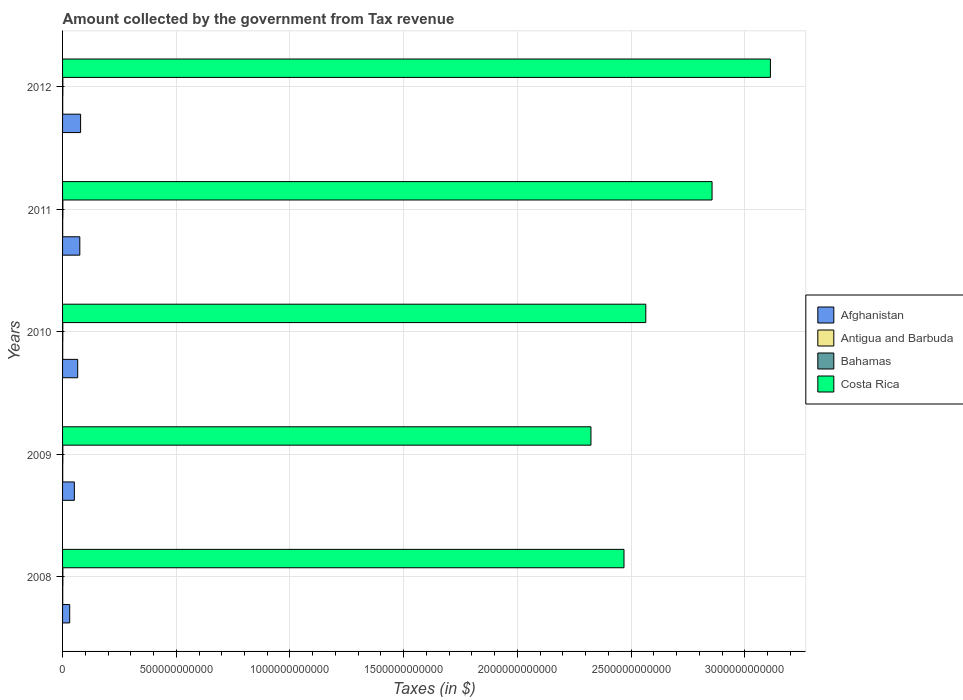How many different coloured bars are there?
Provide a short and direct response. 4. How many groups of bars are there?
Make the answer very short. 5. Are the number of bars on each tick of the Y-axis equal?
Provide a succinct answer. Yes. How many bars are there on the 1st tick from the top?
Give a very brief answer. 4. How many bars are there on the 2nd tick from the bottom?
Keep it short and to the point. 4. What is the label of the 1st group of bars from the top?
Provide a short and direct response. 2012. What is the amount collected by the government from tax revenue in Antigua and Barbuda in 2008?
Provide a succinct answer. 6.92e+08. Across all years, what is the maximum amount collected by the government from tax revenue in Costa Rica?
Keep it short and to the point. 3.11e+12. Across all years, what is the minimum amount collected by the government from tax revenue in Afghanistan?
Provide a short and direct response. 3.14e+1. In which year was the amount collected by the government from tax revenue in Afghanistan maximum?
Make the answer very short. 2012. What is the total amount collected by the government from tax revenue in Antigua and Barbuda in the graph?
Your response must be concise. 3.00e+09. What is the difference between the amount collected by the government from tax revenue in Costa Rica in 2010 and that in 2012?
Ensure brevity in your answer.  -5.48e+11. What is the difference between the amount collected by the government from tax revenue in Afghanistan in 2010 and the amount collected by the government from tax revenue in Antigua and Barbuda in 2012?
Ensure brevity in your answer.  6.60e+1. What is the average amount collected by the government from tax revenue in Antigua and Barbuda per year?
Keep it short and to the point. 6.00e+08. In the year 2011, what is the difference between the amount collected by the government from tax revenue in Bahamas and amount collected by the government from tax revenue in Costa Rica?
Provide a short and direct response. -2.85e+12. In how many years, is the amount collected by the government from tax revenue in Costa Rica greater than 1300000000000 $?
Offer a terse response. 5. What is the ratio of the amount collected by the government from tax revenue in Bahamas in 2008 to that in 2010?
Your response must be concise. 1.16. Is the difference between the amount collected by the government from tax revenue in Bahamas in 2011 and 2012 greater than the difference between the amount collected by the government from tax revenue in Costa Rica in 2011 and 2012?
Provide a short and direct response. Yes. What is the difference between the highest and the second highest amount collected by the government from tax revenue in Antigua and Barbuda?
Your response must be concise. 8.82e+07. What is the difference between the highest and the lowest amount collected by the government from tax revenue in Costa Rica?
Offer a terse response. 7.89e+11. In how many years, is the amount collected by the government from tax revenue in Costa Rica greater than the average amount collected by the government from tax revenue in Costa Rica taken over all years?
Your response must be concise. 2. Is it the case that in every year, the sum of the amount collected by the government from tax revenue in Bahamas and amount collected by the government from tax revenue in Antigua and Barbuda is greater than the sum of amount collected by the government from tax revenue in Costa Rica and amount collected by the government from tax revenue in Afghanistan?
Keep it short and to the point. No. What does the 4th bar from the top in 2011 represents?
Keep it short and to the point. Afghanistan. What does the 1st bar from the bottom in 2009 represents?
Ensure brevity in your answer.  Afghanistan. Is it the case that in every year, the sum of the amount collected by the government from tax revenue in Afghanistan and amount collected by the government from tax revenue in Antigua and Barbuda is greater than the amount collected by the government from tax revenue in Bahamas?
Keep it short and to the point. Yes. Are all the bars in the graph horizontal?
Your answer should be compact. Yes. How many years are there in the graph?
Keep it short and to the point. 5. What is the difference between two consecutive major ticks on the X-axis?
Your answer should be very brief. 5.00e+11. Where does the legend appear in the graph?
Give a very brief answer. Center right. How many legend labels are there?
Offer a very short reply. 4. How are the legend labels stacked?
Ensure brevity in your answer.  Vertical. What is the title of the graph?
Ensure brevity in your answer.  Amount collected by the government from Tax revenue. Does "St. Vincent and the Grenadines" appear as one of the legend labels in the graph?
Provide a short and direct response. No. What is the label or title of the X-axis?
Your response must be concise. Taxes (in $). What is the Taxes (in $) in Afghanistan in 2008?
Provide a short and direct response. 3.14e+1. What is the Taxes (in $) of Antigua and Barbuda in 2008?
Give a very brief answer. 6.92e+08. What is the Taxes (in $) of Bahamas in 2008?
Offer a terse response. 1.28e+09. What is the Taxes (in $) in Costa Rica in 2008?
Offer a terse response. 2.47e+12. What is the Taxes (in $) in Afghanistan in 2009?
Your response must be concise. 5.19e+1. What is the Taxes (in $) in Antigua and Barbuda in 2009?
Provide a succinct answer. 5.73e+08. What is the Taxes (in $) in Bahamas in 2009?
Keep it short and to the point. 1.12e+09. What is the Taxes (in $) in Costa Rica in 2009?
Provide a short and direct response. 2.32e+12. What is the Taxes (in $) of Afghanistan in 2010?
Provide a short and direct response. 6.66e+1. What is the Taxes (in $) of Antigua and Barbuda in 2010?
Provide a short and direct response. 5.76e+08. What is the Taxes (in $) in Bahamas in 2010?
Give a very brief answer. 1.10e+09. What is the Taxes (in $) in Costa Rica in 2010?
Offer a terse response. 2.56e+12. What is the Taxes (in $) in Afghanistan in 2011?
Offer a terse response. 7.58e+1. What is the Taxes (in $) in Antigua and Barbuda in 2011?
Give a very brief answer. 5.51e+08. What is the Taxes (in $) in Bahamas in 2011?
Your answer should be very brief. 1.30e+09. What is the Taxes (in $) of Costa Rica in 2011?
Keep it short and to the point. 2.86e+12. What is the Taxes (in $) in Afghanistan in 2012?
Keep it short and to the point. 7.93e+1. What is the Taxes (in $) in Antigua and Barbuda in 2012?
Keep it short and to the point. 6.04e+08. What is the Taxes (in $) of Bahamas in 2012?
Offer a terse response. 1.28e+09. What is the Taxes (in $) of Costa Rica in 2012?
Make the answer very short. 3.11e+12. Across all years, what is the maximum Taxes (in $) in Afghanistan?
Provide a short and direct response. 7.93e+1. Across all years, what is the maximum Taxes (in $) in Antigua and Barbuda?
Keep it short and to the point. 6.92e+08. Across all years, what is the maximum Taxes (in $) in Bahamas?
Make the answer very short. 1.30e+09. Across all years, what is the maximum Taxes (in $) in Costa Rica?
Provide a short and direct response. 3.11e+12. Across all years, what is the minimum Taxes (in $) in Afghanistan?
Your answer should be very brief. 3.14e+1. Across all years, what is the minimum Taxes (in $) of Antigua and Barbuda?
Provide a short and direct response. 5.51e+08. Across all years, what is the minimum Taxes (in $) of Bahamas?
Ensure brevity in your answer.  1.10e+09. Across all years, what is the minimum Taxes (in $) of Costa Rica?
Give a very brief answer. 2.32e+12. What is the total Taxes (in $) in Afghanistan in the graph?
Ensure brevity in your answer.  3.05e+11. What is the total Taxes (in $) of Antigua and Barbuda in the graph?
Your answer should be compact. 3.00e+09. What is the total Taxes (in $) of Bahamas in the graph?
Ensure brevity in your answer.  6.07e+09. What is the total Taxes (in $) of Costa Rica in the graph?
Your answer should be compact. 1.33e+13. What is the difference between the Taxes (in $) of Afghanistan in 2008 and that in 2009?
Ensure brevity in your answer.  -2.05e+1. What is the difference between the Taxes (in $) in Antigua and Barbuda in 2008 and that in 2009?
Make the answer very short. 1.19e+08. What is the difference between the Taxes (in $) of Bahamas in 2008 and that in 2009?
Offer a very short reply. 1.53e+08. What is the difference between the Taxes (in $) in Costa Rica in 2008 and that in 2009?
Give a very brief answer. 1.45e+11. What is the difference between the Taxes (in $) of Afghanistan in 2008 and that in 2010?
Provide a short and direct response. -3.52e+1. What is the difference between the Taxes (in $) of Antigua and Barbuda in 2008 and that in 2010?
Give a very brief answer. 1.16e+08. What is the difference between the Taxes (in $) of Bahamas in 2008 and that in 2010?
Your response must be concise. 1.78e+08. What is the difference between the Taxes (in $) of Costa Rica in 2008 and that in 2010?
Your answer should be compact. -9.58e+1. What is the difference between the Taxes (in $) in Afghanistan in 2008 and that in 2011?
Make the answer very short. -4.45e+1. What is the difference between the Taxes (in $) of Antigua and Barbuda in 2008 and that in 2011?
Your answer should be very brief. 1.41e+08. What is the difference between the Taxes (in $) of Bahamas in 2008 and that in 2011?
Your answer should be very brief. -2.10e+07. What is the difference between the Taxes (in $) in Costa Rica in 2008 and that in 2011?
Make the answer very short. -3.87e+11. What is the difference between the Taxes (in $) of Afghanistan in 2008 and that in 2012?
Keep it short and to the point. -4.79e+1. What is the difference between the Taxes (in $) of Antigua and Barbuda in 2008 and that in 2012?
Your answer should be very brief. 8.82e+07. What is the difference between the Taxes (in $) of Bahamas in 2008 and that in 2012?
Offer a terse response. -7.50e+05. What is the difference between the Taxes (in $) in Costa Rica in 2008 and that in 2012?
Your answer should be compact. -6.44e+11. What is the difference between the Taxes (in $) in Afghanistan in 2009 and that in 2010?
Your response must be concise. -1.47e+1. What is the difference between the Taxes (in $) of Antigua and Barbuda in 2009 and that in 2010?
Your answer should be compact. -3.10e+06. What is the difference between the Taxes (in $) of Bahamas in 2009 and that in 2010?
Your response must be concise. 2.51e+07. What is the difference between the Taxes (in $) in Costa Rica in 2009 and that in 2010?
Provide a short and direct response. -2.41e+11. What is the difference between the Taxes (in $) in Afghanistan in 2009 and that in 2011?
Offer a very short reply. -2.39e+1. What is the difference between the Taxes (in $) in Antigua and Barbuda in 2009 and that in 2011?
Provide a short and direct response. 2.20e+07. What is the difference between the Taxes (in $) of Bahamas in 2009 and that in 2011?
Your answer should be compact. -1.74e+08. What is the difference between the Taxes (in $) in Costa Rica in 2009 and that in 2011?
Your response must be concise. -5.33e+11. What is the difference between the Taxes (in $) in Afghanistan in 2009 and that in 2012?
Provide a succinct answer. -2.74e+1. What is the difference between the Taxes (in $) in Antigua and Barbuda in 2009 and that in 2012?
Keep it short and to the point. -3.08e+07. What is the difference between the Taxes (in $) in Bahamas in 2009 and that in 2012?
Your response must be concise. -1.53e+08. What is the difference between the Taxes (in $) in Costa Rica in 2009 and that in 2012?
Ensure brevity in your answer.  -7.89e+11. What is the difference between the Taxes (in $) in Afghanistan in 2010 and that in 2011?
Provide a short and direct response. -9.23e+09. What is the difference between the Taxes (in $) in Antigua and Barbuda in 2010 and that in 2011?
Provide a short and direct response. 2.51e+07. What is the difference between the Taxes (in $) in Bahamas in 2010 and that in 2011?
Ensure brevity in your answer.  -1.99e+08. What is the difference between the Taxes (in $) in Costa Rica in 2010 and that in 2011?
Your response must be concise. -2.91e+11. What is the difference between the Taxes (in $) of Afghanistan in 2010 and that in 2012?
Provide a succinct answer. -1.27e+1. What is the difference between the Taxes (in $) in Antigua and Barbuda in 2010 and that in 2012?
Keep it short and to the point. -2.77e+07. What is the difference between the Taxes (in $) in Bahamas in 2010 and that in 2012?
Offer a very short reply. -1.79e+08. What is the difference between the Taxes (in $) in Costa Rica in 2010 and that in 2012?
Your answer should be compact. -5.48e+11. What is the difference between the Taxes (in $) in Afghanistan in 2011 and that in 2012?
Your answer should be compact. -3.47e+09. What is the difference between the Taxes (in $) in Antigua and Barbuda in 2011 and that in 2012?
Offer a very short reply. -5.28e+07. What is the difference between the Taxes (in $) in Bahamas in 2011 and that in 2012?
Offer a terse response. 2.03e+07. What is the difference between the Taxes (in $) of Costa Rica in 2011 and that in 2012?
Your answer should be compact. -2.57e+11. What is the difference between the Taxes (in $) of Afghanistan in 2008 and the Taxes (in $) of Antigua and Barbuda in 2009?
Your response must be concise. 3.08e+1. What is the difference between the Taxes (in $) in Afghanistan in 2008 and the Taxes (in $) in Bahamas in 2009?
Ensure brevity in your answer.  3.02e+1. What is the difference between the Taxes (in $) in Afghanistan in 2008 and the Taxes (in $) in Costa Rica in 2009?
Ensure brevity in your answer.  -2.29e+12. What is the difference between the Taxes (in $) of Antigua and Barbuda in 2008 and the Taxes (in $) of Bahamas in 2009?
Give a very brief answer. -4.31e+08. What is the difference between the Taxes (in $) of Antigua and Barbuda in 2008 and the Taxes (in $) of Costa Rica in 2009?
Make the answer very short. -2.32e+12. What is the difference between the Taxes (in $) of Bahamas in 2008 and the Taxes (in $) of Costa Rica in 2009?
Your answer should be compact. -2.32e+12. What is the difference between the Taxes (in $) in Afghanistan in 2008 and the Taxes (in $) in Antigua and Barbuda in 2010?
Offer a very short reply. 3.08e+1. What is the difference between the Taxes (in $) of Afghanistan in 2008 and the Taxes (in $) of Bahamas in 2010?
Offer a very short reply. 3.03e+1. What is the difference between the Taxes (in $) in Afghanistan in 2008 and the Taxes (in $) in Costa Rica in 2010?
Make the answer very short. -2.53e+12. What is the difference between the Taxes (in $) in Antigua and Barbuda in 2008 and the Taxes (in $) in Bahamas in 2010?
Ensure brevity in your answer.  -4.06e+08. What is the difference between the Taxes (in $) of Antigua and Barbuda in 2008 and the Taxes (in $) of Costa Rica in 2010?
Keep it short and to the point. -2.56e+12. What is the difference between the Taxes (in $) of Bahamas in 2008 and the Taxes (in $) of Costa Rica in 2010?
Keep it short and to the point. -2.56e+12. What is the difference between the Taxes (in $) in Afghanistan in 2008 and the Taxes (in $) in Antigua and Barbuda in 2011?
Give a very brief answer. 3.08e+1. What is the difference between the Taxes (in $) in Afghanistan in 2008 and the Taxes (in $) in Bahamas in 2011?
Provide a short and direct response. 3.01e+1. What is the difference between the Taxes (in $) of Afghanistan in 2008 and the Taxes (in $) of Costa Rica in 2011?
Your response must be concise. -2.82e+12. What is the difference between the Taxes (in $) in Antigua and Barbuda in 2008 and the Taxes (in $) in Bahamas in 2011?
Provide a succinct answer. -6.05e+08. What is the difference between the Taxes (in $) of Antigua and Barbuda in 2008 and the Taxes (in $) of Costa Rica in 2011?
Make the answer very short. -2.86e+12. What is the difference between the Taxes (in $) of Bahamas in 2008 and the Taxes (in $) of Costa Rica in 2011?
Your answer should be very brief. -2.85e+12. What is the difference between the Taxes (in $) of Afghanistan in 2008 and the Taxes (in $) of Antigua and Barbuda in 2012?
Your answer should be very brief. 3.08e+1. What is the difference between the Taxes (in $) in Afghanistan in 2008 and the Taxes (in $) in Bahamas in 2012?
Provide a short and direct response. 3.01e+1. What is the difference between the Taxes (in $) of Afghanistan in 2008 and the Taxes (in $) of Costa Rica in 2012?
Provide a succinct answer. -3.08e+12. What is the difference between the Taxes (in $) in Antigua and Barbuda in 2008 and the Taxes (in $) in Bahamas in 2012?
Your answer should be compact. -5.84e+08. What is the difference between the Taxes (in $) of Antigua and Barbuda in 2008 and the Taxes (in $) of Costa Rica in 2012?
Provide a short and direct response. -3.11e+12. What is the difference between the Taxes (in $) in Bahamas in 2008 and the Taxes (in $) in Costa Rica in 2012?
Keep it short and to the point. -3.11e+12. What is the difference between the Taxes (in $) in Afghanistan in 2009 and the Taxes (in $) in Antigua and Barbuda in 2010?
Offer a terse response. 5.13e+1. What is the difference between the Taxes (in $) in Afghanistan in 2009 and the Taxes (in $) in Bahamas in 2010?
Ensure brevity in your answer.  5.08e+1. What is the difference between the Taxes (in $) in Afghanistan in 2009 and the Taxes (in $) in Costa Rica in 2010?
Offer a very short reply. -2.51e+12. What is the difference between the Taxes (in $) in Antigua and Barbuda in 2009 and the Taxes (in $) in Bahamas in 2010?
Provide a short and direct response. -5.25e+08. What is the difference between the Taxes (in $) in Antigua and Barbuda in 2009 and the Taxes (in $) in Costa Rica in 2010?
Offer a terse response. -2.56e+12. What is the difference between the Taxes (in $) in Bahamas in 2009 and the Taxes (in $) in Costa Rica in 2010?
Your answer should be compact. -2.56e+12. What is the difference between the Taxes (in $) of Afghanistan in 2009 and the Taxes (in $) of Antigua and Barbuda in 2011?
Offer a very short reply. 5.13e+1. What is the difference between the Taxes (in $) of Afghanistan in 2009 and the Taxes (in $) of Bahamas in 2011?
Give a very brief answer. 5.06e+1. What is the difference between the Taxes (in $) of Afghanistan in 2009 and the Taxes (in $) of Costa Rica in 2011?
Provide a succinct answer. -2.80e+12. What is the difference between the Taxes (in $) in Antigua and Barbuda in 2009 and the Taxes (in $) in Bahamas in 2011?
Make the answer very short. -7.24e+08. What is the difference between the Taxes (in $) of Antigua and Barbuda in 2009 and the Taxes (in $) of Costa Rica in 2011?
Provide a succinct answer. -2.86e+12. What is the difference between the Taxes (in $) of Bahamas in 2009 and the Taxes (in $) of Costa Rica in 2011?
Ensure brevity in your answer.  -2.86e+12. What is the difference between the Taxes (in $) of Afghanistan in 2009 and the Taxes (in $) of Antigua and Barbuda in 2012?
Give a very brief answer. 5.13e+1. What is the difference between the Taxes (in $) of Afghanistan in 2009 and the Taxes (in $) of Bahamas in 2012?
Your response must be concise. 5.06e+1. What is the difference between the Taxes (in $) in Afghanistan in 2009 and the Taxes (in $) in Costa Rica in 2012?
Offer a very short reply. -3.06e+12. What is the difference between the Taxes (in $) in Antigua and Barbuda in 2009 and the Taxes (in $) in Bahamas in 2012?
Provide a short and direct response. -7.03e+08. What is the difference between the Taxes (in $) in Antigua and Barbuda in 2009 and the Taxes (in $) in Costa Rica in 2012?
Make the answer very short. -3.11e+12. What is the difference between the Taxes (in $) in Bahamas in 2009 and the Taxes (in $) in Costa Rica in 2012?
Your response must be concise. -3.11e+12. What is the difference between the Taxes (in $) in Afghanistan in 2010 and the Taxes (in $) in Antigua and Barbuda in 2011?
Give a very brief answer. 6.60e+1. What is the difference between the Taxes (in $) in Afghanistan in 2010 and the Taxes (in $) in Bahamas in 2011?
Provide a succinct answer. 6.53e+1. What is the difference between the Taxes (in $) of Afghanistan in 2010 and the Taxes (in $) of Costa Rica in 2011?
Give a very brief answer. -2.79e+12. What is the difference between the Taxes (in $) in Antigua and Barbuda in 2010 and the Taxes (in $) in Bahamas in 2011?
Offer a terse response. -7.20e+08. What is the difference between the Taxes (in $) of Antigua and Barbuda in 2010 and the Taxes (in $) of Costa Rica in 2011?
Make the answer very short. -2.86e+12. What is the difference between the Taxes (in $) of Bahamas in 2010 and the Taxes (in $) of Costa Rica in 2011?
Your answer should be very brief. -2.86e+12. What is the difference between the Taxes (in $) in Afghanistan in 2010 and the Taxes (in $) in Antigua and Barbuda in 2012?
Your response must be concise. 6.60e+1. What is the difference between the Taxes (in $) of Afghanistan in 2010 and the Taxes (in $) of Bahamas in 2012?
Give a very brief answer. 6.53e+1. What is the difference between the Taxes (in $) of Afghanistan in 2010 and the Taxes (in $) of Costa Rica in 2012?
Your answer should be compact. -3.05e+12. What is the difference between the Taxes (in $) in Antigua and Barbuda in 2010 and the Taxes (in $) in Bahamas in 2012?
Offer a terse response. -7.00e+08. What is the difference between the Taxes (in $) of Antigua and Barbuda in 2010 and the Taxes (in $) of Costa Rica in 2012?
Give a very brief answer. -3.11e+12. What is the difference between the Taxes (in $) in Bahamas in 2010 and the Taxes (in $) in Costa Rica in 2012?
Your answer should be compact. -3.11e+12. What is the difference between the Taxes (in $) of Afghanistan in 2011 and the Taxes (in $) of Antigua and Barbuda in 2012?
Your answer should be compact. 7.52e+1. What is the difference between the Taxes (in $) in Afghanistan in 2011 and the Taxes (in $) in Bahamas in 2012?
Offer a very short reply. 7.45e+1. What is the difference between the Taxes (in $) of Afghanistan in 2011 and the Taxes (in $) of Costa Rica in 2012?
Your answer should be very brief. -3.04e+12. What is the difference between the Taxes (in $) in Antigua and Barbuda in 2011 and the Taxes (in $) in Bahamas in 2012?
Provide a short and direct response. -7.25e+08. What is the difference between the Taxes (in $) in Antigua and Barbuda in 2011 and the Taxes (in $) in Costa Rica in 2012?
Provide a succinct answer. -3.11e+12. What is the difference between the Taxes (in $) in Bahamas in 2011 and the Taxes (in $) in Costa Rica in 2012?
Keep it short and to the point. -3.11e+12. What is the average Taxes (in $) of Afghanistan per year?
Your answer should be compact. 6.10e+1. What is the average Taxes (in $) in Antigua and Barbuda per year?
Offer a very short reply. 6.00e+08. What is the average Taxes (in $) of Bahamas per year?
Offer a very short reply. 1.21e+09. What is the average Taxes (in $) of Costa Rica per year?
Ensure brevity in your answer.  2.67e+12. In the year 2008, what is the difference between the Taxes (in $) of Afghanistan and Taxes (in $) of Antigua and Barbuda?
Ensure brevity in your answer.  3.07e+1. In the year 2008, what is the difference between the Taxes (in $) in Afghanistan and Taxes (in $) in Bahamas?
Provide a short and direct response. 3.01e+1. In the year 2008, what is the difference between the Taxes (in $) of Afghanistan and Taxes (in $) of Costa Rica?
Give a very brief answer. -2.44e+12. In the year 2008, what is the difference between the Taxes (in $) in Antigua and Barbuda and Taxes (in $) in Bahamas?
Offer a very short reply. -5.83e+08. In the year 2008, what is the difference between the Taxes (in $) of Antigua and Barbuda and Taxes (in $) of Costa Rica?
Ensure brevity in your answer.  -2.47e+12. In the year 2008, what is the difference between the Taxes (in $) in Bahamas and Taxes (in $) in Costa Rica?
Provide a succinct answer. -2.47e+12. In the year 2009, what is the difference between the Taxes (in $) of Afghanistan and Taxes (in $) of Antigua and Barbuda?
Your answer should be compact. 5.13e+1. In the year 2009, what is the difference between the Taxes (in $) in Afghanistan and Taxes (in $) in Bahamas?
Your response must be concise. 5.08e+1. In the year 2009, what is the difference between the Taxes (in $) of Afghanistan and Taxes (in $) of Costa Rica?
Provide a succinct answer. -2.27e+12. In the year 2009, what is the difference between the Taxes (in $) in Antigua and Barbuda and Taxes (in $) in Bahamas?
Give a very brief answer. -5.50e+08. In the year 2009, what is the difference between the Taxes (in $) of Antigua and Barbuda and Taxes (in $) of Costa Rica?
Your answer should be very brief. -2.32e+12. In the year 2009, what is the difference between the Taxes (in $) in Bahamas and Taxes (in $) in Costa Rica?
Provide a short and direct response. -2.32e+12. In the year 2010, what is the difference between the Taxes (in $) in Afghanistan and Taxes (in $) in Antigua and Barbuda?
Provide a succinct answer. 6.60e+1. In the year 2010, what is the difference between the Taxes (in $) of Afghanistan and Taxes (in $) of Bahamas?
Give a very brief answer. 6.55e+1. In the year 2010, what is the difference between the Taxes (in $) of Afghanistan and Taxes (in $) of Costa Rica?
Your answer should be compact. -2.50e+12. In the year 2010, what is the difference between the Taxes (in $) of Antigua and Barbuda and Taxes (in $) of Bahamas?
Ensure brevity in your answer.  -5.22e+08. In the year 2010, what is the difference between the Taxes (in $) in Antigua and Barbuda and Taxes (in $) in Costa Rica?
Your answer should be very brief. -2.56e+12. In the year 2010, what is the difference between the Taxes (in $) of Bahamas and Taxes (in $) of Costa Rica?
Offer a terse response. -2.56e+12. In the year 2011, what is the difference between the Taxes (in $) of Afghanistan and Taxes (in $) of Antigua and Barbuda?
Make the answer very short. 7.53e+1. In the year 2011, what is the difference between the Taxes (in $) in Afghanistan and Taxes (in $) in Bahamas?
Give a very brief answer. 7.45e+1. In the year 2011, what is the difference between the Taxes (in $) in Afghanistan and Taxes (in $) in Costa Rica?
Give a very brief answer. -2.78e+12. In the year 2011, what is the difference between the Taxes (in $) in Antigua and Barbuda and Taxes (in $) in Bahamas?
Make the answer very short. -7.46e+08. In the year 2011, what is the difference between the Taxes (in $) in Antigua and Barbuda and Taxes (in $) in Costa Rica?
Your answer should be compact. -2.86e+12. In the year 2011, what is the difference between the Taxes (in $) of Bahamas and Taxes (in $) of Costa Rica?
Offer a terse response. -2.85e+12. In the year 2012, what is the difference between the Taxes (in $) of Afghanistan and Taxes (in $) of Antigua and Barbuda?
Offer a terse response. 7.87e+1. In the year 2012, what is the difference between the Taxes (in $) of Afghanistan and Taxes (in $) of Bahamas?
Ensure brevity in your answer.  7.80e+1. In the year 2012, what is the difference between the Taxes (in $) in Afghanistan and Taxes (in $) in Costa Rica?
Offer a very short reply. -3.03e+12. In the year 2012, what is the difference between the Taxes (in $) of Antigua and Barbuda and Taxes (in $) of Bahamas?
Your response must be concise. -6.72e+08. In the year 2012, what is the difference between the Taxes (in $) of Antigua and Barbuda and Taxes (in $) of Costa Rica?
Give a very brief answer. -3.11e+12. In the year 2012, what is the difference between the Taxes (in $) in Bahamas and Taxes (in $) in Costa Rica?
Your answer should be very brief. -3.11e+12. What is the ratio of the Taxes (in $) of Afghanistan in 2008 to that in 2009?
Your answer should be very brief. 0.6. What is the ratio of the Taxes (in $) of Antigua and Barbuda in 2008 to that in 2009?
Offer a very short reply. 1.21. What is the ratio of the Taxes (in $) in Bahamas in 2008 to that in 2009?
Offer a very short reply. 1.14. What is the ratio of the Taxes (in $) in Costa Rica in 2008 to that in 2009?
Make the answer very short. 1.06. What is the ratio of the Taxes (in $) of Afghanistan in 2008 to that in 2010?
Your response must be concise. 0.47. What is the ratio of the Taxes (in $) in Antigua and Barbuda in 2008 to that in 2010?
Offer a very short reply. 1.2. What is the ratio of the Taxes (in $) of Bahamas in 2008 to that in 2010?
Keep it short and to the point. 1.16. What is the ratio of the Taxes (in $) of Costa Rica in 2008 to that in 2010?
Your answer should be very brief. 0.96. What is the ratio of the Taxes (in $) of Afghanistan in 2008 to that in 2011?
Offer a very short reply. 0.41. What is the ratio of the Taxes (in $) of Antigua and Barbuda in 2008 to that in 2011?
Provide a succinct answer. 1.26. What is the ratio of the Taxes (in $) of Bahamas in 2008 to that in 2011?
Keep it short and to the point. 0.98. What is the ratio of the Taxes (in $) in Costa Rica in 2008 to that in 2011?
Provide a succinct answer. 0.86. What is the ratio of the Taxes (in $) of Afghanistan in 2008 to that in 2012?
Your answer should be compact. 0.4. What is the ratio of the Taxes (in $) of Antigua and Barbuda in 2008 to that in 2012?
Offer a very short reply. 1.15. What is the ratio of the Taxes (in $) in Bahamas in 2008 to that in 2012?
Ensure brevity in your answer.  1. What is the ratio of the Taxes (in $) of Costa Rica in 2008 to that in 2012?
Offer a terse response. 0.79. What is the ratio of the Taxes (in $) in Afghanistan in 2009 to that in 2010?
Make the answer very short. 0.78. What is the ratio of the Taxes (in $) of Antigua and Barbuda in 2009 to that in 2010?
Offer a terse response. 0.99. What is the ratio of the Taxes (in $) in Bahamas in 2009 to that in 2010?
Keep it short and to the point. 1.02. What is the ratio of the Taxes (in $) in Costa Rica in 2009 to that in 2010?
Offer a terse response. 0.91. What is the ratio of the Taxes (in $) of Afghanistan in 2009 to that in 2011?
Give a very brief answer. 0.68. What is the ratio of the Taxes (in $) in Antigua and Barbuda in 2009 to that in 2011?
Keep it short and to the point. 1.04. What is the ratio of the Taxes (in $) in Bahamas in 2009 to that in 2011?
Make the answer very short. 0.87. What is the ratio of the Taxes (in $) in Costa Rica in 2009 to that in 2011?
Provide a short and direct response. 0.81. What is the ratio of the Taxes (in $) in Afghanistan in 2009 to that in 2012?
Provide a succinct answer. 0.65. What is the ratio of the Taxes (in $) of Antigua and Barbuda in 2009 to that in 2012?
Offer a terse response. 0.95. What is the ratio of the Taxes (in $) of Bahamas in 2009 to that in 2012?
Provide a succinct answer. 0.88. What is the ratio of the Taxes (in $) of Costa Rica in 2009 to that in 2012?
Your response must be concise. 0.75. What is the ratio of the Taxes (in $) of Afghanistan in 2010 to that in 2011?
Your response must be concise. 0.88. What is the ratio of the Taxes (in $) in Antigua and Barbuda in 2010 to that in 2011?
Ensure brevity in your answer.  1.05. What is the ratio of the Taxes (in $) of Bahamas in 2010 to that in 2011?
Your response must be concise. 0.85. What is the ratio of the Taxes (in $) in Costa Rica in 2010 to that in 2011?
Offer a very short reply. 0.9. What is the ratio of the Taxes (in $) of Afghanistan in 2010 to that in 2012?
Provide a succinct answer. 0.84. What is the ratio of the Taxes (in $) of Antigua and Barbuda in 2010 to that in 2012?
Provide a short and direct response. 0.95. What is the ratio of the Taxes (in $) of Bahamas in 2010 to that in 2012?
Provide a succinct answer. 0.86. What is the ratio of the Taxes (in $) of Costa Rica in 2010 to that in 2012?
Your answer should be very brief. 0.82. What is the ratio of the Taxes (in $) in Afghanistan in 2011 to that in 2012?
Keep it short and to the point. 0.96. What is the ratio of the Taxes (in $) of Antigua and Barbuda in 2011 to that in 2012?
Provide a succinct answer. 0.91. What is the ratio of the Taxes (in $) of Bahamas in 2011 to that in 2012?
Your response must be concise. 1.02. What is the ratio of the Taxes (in $) of Costa Rica in 2011 to that in 2012?
Your answer should be very brief. 0.92. What is the difference between the highest and the second highest Taxes (in $) of Afghanistan?
Your response must be concise. 3.47e+09. What is the difference between the highest and the second highest Taxes (in $) in Antigua and Barbuda?
Make the answer very short. 8.82e+07. What is the difference between the highest and the second highest Taxes (in $) in Bahamas?
Offer a terse response. 2.03e+07. What is the difference between the highest and the second highest Taxes (in $) in Costa Rica?
Ensure brevity in your answer.  2.57e+11. What is the difference between the highest and the lowest Taxes (in $) in Afghanistan?
Provide a succinct answer. 4.79e+1. What is the difference between the highest and the lowest Taxes (in $) of Antigua and Barbuda?
Keep it short and to the point. 1.41e+08. What is the difference between the highest and the lowest Taxes (in $) in Bahamas?
Provide a short and direct response. 1.99e+08. What is the difference between the highest and the lowest Taxes (in $) of Costa Rica?
Keep it short and to the point. 7.89e+11. 